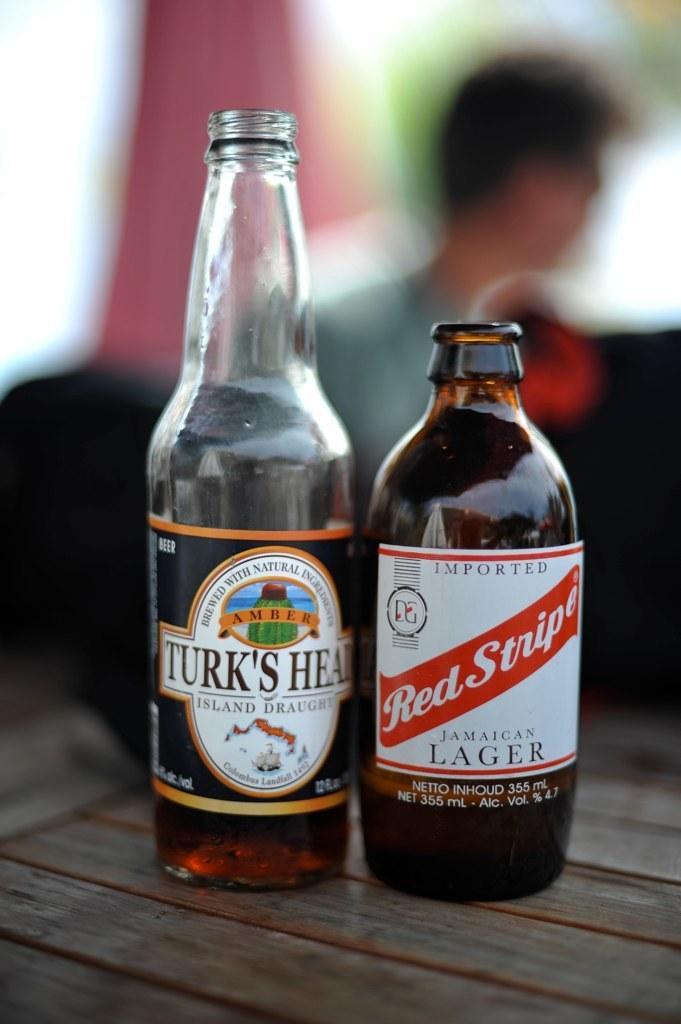In one or two sentences, can you explain what this image depicts? There are two wine bottles on a table. 